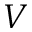<formula> <loc_0><loc_0><loc_500><loc_500>V</formula> 